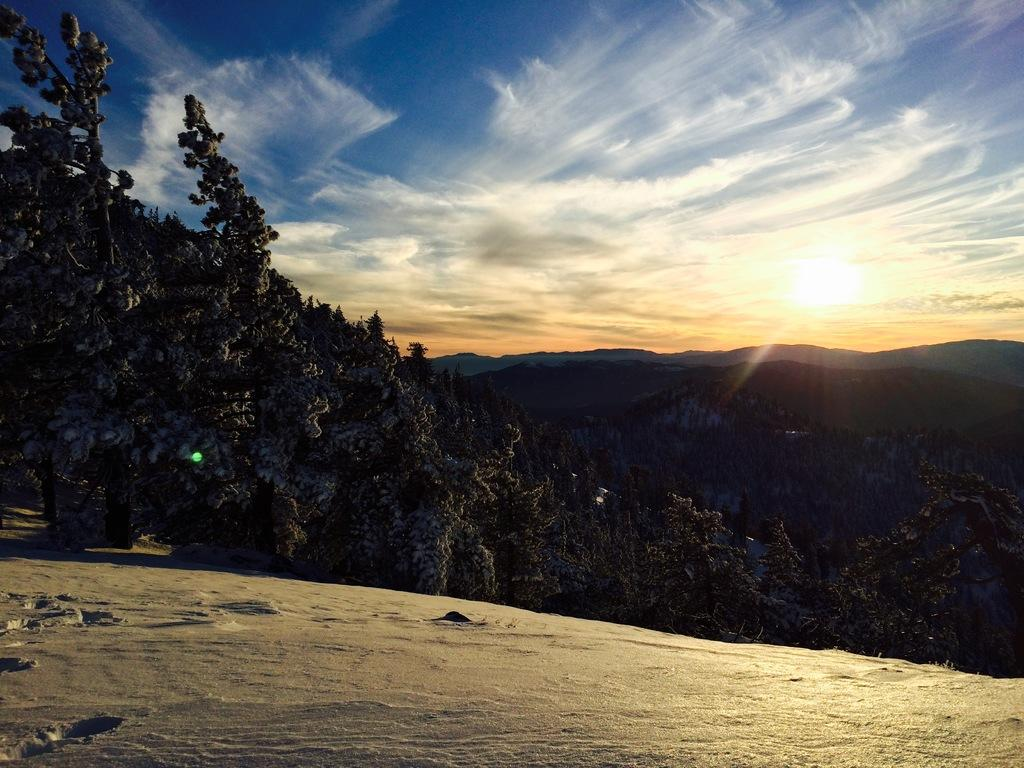What type of vegetation is present on the ground in the image? There are trees on the ground in the image. What type of natural formation can be seen in the background of the image? There are mountains in the background of the image. What part of the natural environment is visible in the background of the image? The sky is visible in the background of the image. What type of acoustics can be heard in the image? There is no sound or acoustics present in the image, as it is a still photograph. How many books are visible in the image? There are no books present in the image. 